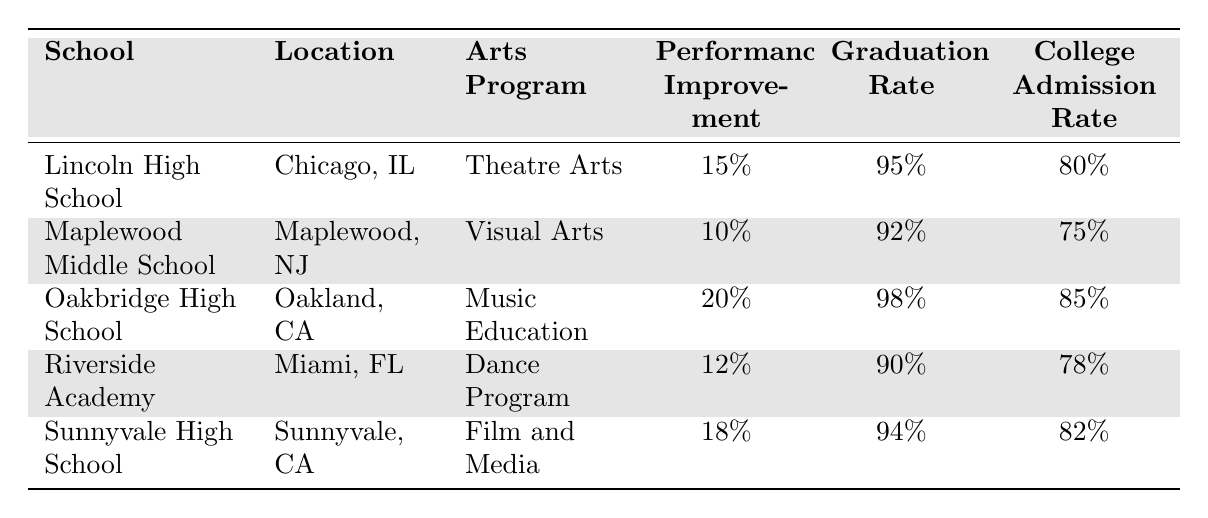What is the arts program offered at Lincoln High School? The table lists the arts program associated with Lincoln High School, which is Theatre Arts.
Answer: Theatre Arts Which school has the highest college admission rate? By examining the college admission rates in the table, Oakbridge High School has the highest rate at 85%.
Answer: Oakbridge High School What is the student performance improvement percentage for Sunnyvale High School? The table specifies that Sunnyvale High School has a student performance improvement of 18%.
Answer: 18% What is the difference in graduation rates between Oakbridge High School and Riverside Academy? The graduation rate for Oakbridge High School is 98%, and for Riverside Academy, it is 90%. The difference is 98% - 90% = 8%.
Answer: 8% Is the college admission rate for Maplewood Middle School greater than the graduation rate? The college admission rate for Maplewood Middle School is 75%, while the graduation rate is 92%. Since 75% is less than 92%, the statement is false.
Answer: No What is the average student performance improvement across all schools listed? To find the average, sum the improvements: 15% + 10% + 20% + 12% + 18% = 75%. There are 5 schools, so the average is 75% / 5 = 15%.
Answer: 15% Which arts program has the lowest student performance improvement percentage? By comparing the student performance improvement percentages, Visual Arts at Maplewood Middle School has the lowest at 10%.
Answer: Visual Arts How many schools have a graduation rate above 90%? The schools with graduation rates above 90% are Lincoln High School (95%), Oakbridge High School (98%), and Sunnyvale High School (94%). This totals to three schools.
Answer: 3 What is the overall college admission rate for the schools listed? To find this, sum the college admission rates: 80% + 75% + 85% + 78% + 82% = 400%. Divide by 5 schools for the average: 400% / 5 = 80%.
Answer: 80% Which school has the lowest student performance improvement among those offering dance programs? Riverside Academy, which offers a Dance Program, has a performance improvement of 12%, making it the lowest among the listed schools for this program.
Answer: Riverside Academy 